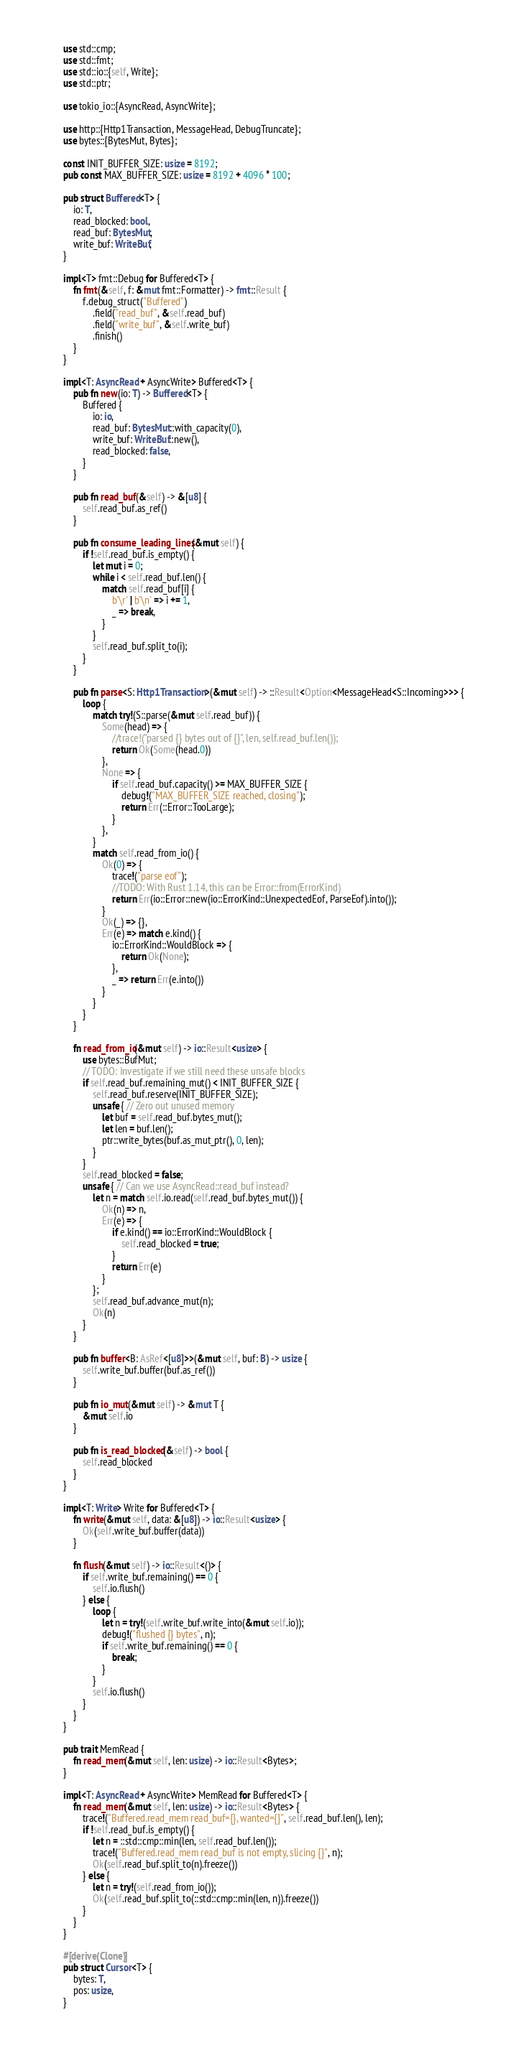<code> <loc_0><loc_0><loc_500><loc_500><_Rust_>use std::cmp;
use std::fmt;
use std::io::{self, Write};
use std::ptr;

use tokio_io::{AsyncRead, AsyncWrite};

use http::{Http1Transaction, MessageHead, DebugTruncate};
use bytes::{BytesMut, Bytes};

const INIT_BUFFER_SIZE: usize = 8192;
pub const MAX_BUFFER_SIZE: usize = 8192 + 4096 * 100;

pub struct Buffered<T> {
    io: T,
    read_blocked: bool,
    read_buf: BytesMut,
    write_buf: WriteBuf,
}

impl<T> fmt::Debug for Buffered<T> {
    fn fmt(&self, f: &mut fmt::Formatter) -> fmt::Result {
        f.debug_struct("Buffered")
            .field("read_buf", &self.read_buf)
            .field("write_buf", &self.write_buf)
            .finish()
    }
}

impl<T: AsyncRead + AsyncWrite> Buffered<T> {
    pub fn new(io: T) -> Buffered<T> {
        Buffered {
            io: io,
            read_buf: BytesMut::with_capacity(0),
            write_buf: WriteBuf::new(),
            read_blocked: false,
        }
    }

    pub fn read_buf(&self) -> &[u8] {
        self.read_buf.as_ref()
    }

    pub fn consume_leading_lines(&mut self) {
        if !self.read_buf.is_empty() {
            let mut i = 0;
            while i < self.read_buf.len() {
                match self.read_buf[i] {
                    b'\r' | b'\n' => i += 1,
                    _ => break,
                }
            }
            self.read_buf.split_to(i);
        }
    }

    pub fn parse<S: Http1Transaction>(&mut self) -> ::Result<Option<MessageHead<S::Incoming>>> {
        loop {
            match try!(S::parse(&mut self.read_buf)) {
                Some(head) => {
                    //trace!("parsed {} bytes out of {}", len, self.read_buf.len());
                    return Ok(Some(head.0))
                },
                None => {
                    if self.read_buf.capacity() >= MAX_BUFFER_SIZE {
                        debug!("MAX_BUFFER_SIZE reached, closing");
                        return Err(::Error::TooLarge);
                    }
                },
            }
            match self.read_from_io() {
                Ok(0) => {
                    trace!("parse eof");
                    //TODO: With Rust 1.14, this can be Error::from(ErrorKind)
                    return Err(io::Error::new(io::ErrorKind::UnexpectedEof, ParseEof).into());
                }
                Ok(_) => {},
                Err(e) => match e.kind() {
                    io::ErrorKind::WouldBlock => {
                        return Ok(None);
                    },
                    _ => return Err(e.into())
                }
            }
        }
    }

    fn read_from_io(&mut self) -> io::Result<usize> {
        use bytes::BufMut;
        // TODO: Investigate if we still need these unsafe blocks
        if self.read_buf.remaining_mut() < INIT_BUFFER_SIZE {
            self.read_buf.reserve(INIT_BUFFER_SIZE);
            unsafe { // Zero out unused memory
                let buf = self.read_buf.bytes_mut();
                let len = buf.len();
                ptr::write_bytes(buf.as_mut_ptr(), 0, len);
            }
        }
        self.read_blocked = false;
        unsafe { // Can we use AsyncRead::read_buf instead?
            let n = match self.io.read(self.read_buf.bytes_mut()) {
                Ok(n) => n,
                Err(e) => {
                    if e.kind() == io::ErrorKind::WouldBlock {
                        self.read_blocked = true;
                    }
                    return Err(e)
                }
            };
            self.read_buf.advance_mut(n);
            Ok(n)
        }
    }

    pub fn buffer<B: AsRef<[u8]>>(&mut self, buf: B) -> usize {
        self.write_buf.buffer(buf.as_ref())
    }

    pub fn io_mut(&mut self) -> &mut T {
        &mut self.io
    }

    pub fn is_read_blocked(&self) -> bool {
        self.read_blocked
    }
}

impl<T: Write> Write for Buffered<T> {
    fn write(&mut self, data: &[u8]) -> io::Result<usize> {
        Ok(self.write_buf.buffer(data))
    }

    fn flush(&mut self) -> io::Result<()> {
        if self.write_buf.remaining() == 0 {
            self.io.flush()
        } else {
            loop {
                let n = try!(self.write_buf.write_into(&mut self.io));
                debug!("flushed {} bytes", n);
                if self.write_buf.remaining() == 0 {
                    break;
                }
            }
            self.io.flush()
        }
    }
}

pub trait MemRead {
    fn read_mem(&mut self, len: usize) -> io::Result<Bytes>;
}

impl<T: AsyncRead + AsyncWrite> MemRead for Buffered<T> {
    fn read_mem(&mut self, len: usize) -> io::Result<Bytes> {
        trace!("Buffered.read_mem read_buf={}, wanted={}", self.read_buf.len(), len);
        if !self.read_buf.is_empty() {
            let n = ::std::cmp::min(len, self.read_buf.len());
            trace!("Buffered.read_mem read_buf is not empty, slicing {}", n);
            Ok(self.read_buf.split_to(n).freeze())
        } else {
            let n = try!(self.read_from_io());
            Ok(self.read_buf.split_to(::std::cmp::min(len, n)).freeze())
        }
    }
}

#[derive(Clone)]
pub struct Cursor<T> {
    bytes: T,
    pos: usize,
}
</code> 